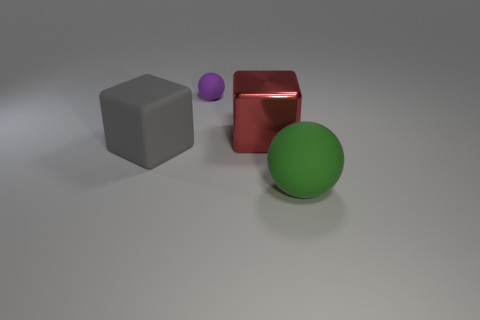Can you describe the lighting in the scene? Certainly! The lighting in the scene is soft and appears to be evenly distributed. There are gentle shadows cast by the objects, suggesting an ambient light source that helps to define their shapes without creating harsh contrasts. 